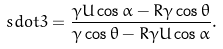Convert formula to latex. <formula><loc_0><loc_0><loc_500><loc_500>\ s d o t { 3 } = \frac { \gamma U \cos \alpha - R \gamma \cos \theta } { \gamma \cos \theta - R \gamma U \cos \alpha } .</formula> 